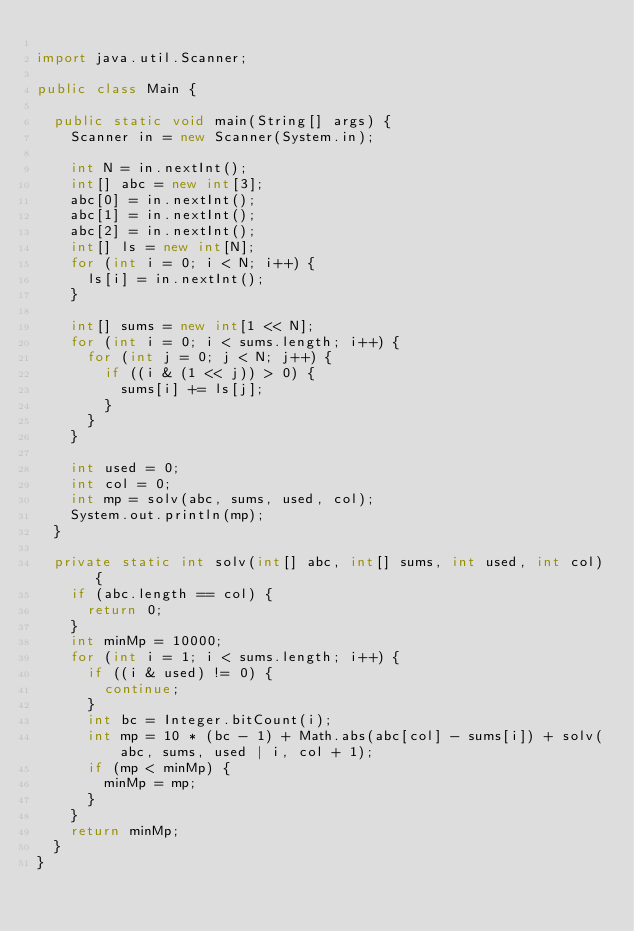<code> <loc_0><loc_0><loc_500><loc_500><_Java_>
import java.util.Scanner;

public class Main {

	public static void main(String[] args) {
		Scanner in = new Scanner(System.in);

		int N = in.nextInt();
		int[] abc = new int[3];
		abc[0] = in.nextInt();
		abc[1] = in.nextInt();
		abc[2] = in.nextInt();
		int[] ls = new int[N];
		for (int i = 0; i < N; i++) {
			ls[i] = in.nextInt();
		}

		int[] sums = new int[1 << N];
		for (int i = 0; i < sums.length; i++) {
			for (int j = 0; j < N; j++) {
				if ((i & (1 << j)) > 0) {
					sums[i] += ls[j];
				}
			}
		}

		int used = 0;
		int col = 0;
		int mp = solv(abc, sums, used, col);
		System.out.println(mp);
	}

	private static int solv(int[] abc, int[] sums, int used, int col) {
		if (abc.length == col) {
			return 0;
		}
		int minMp = 10000;
		for (int i = 1; i < sums.length; i++) {
			if ((i & used) != 0) {
				continue;
			}
			int bc = Integer.bitCount(i);
			int mp = 10 * (bc - 1) + Math.abs(abc[col] - sums[i]) + solv(abc, sums, used | i, col + 1);
			if (mp < minMp) {
				minMp = mp;
			}
		}
		return minMp;
	}
}
</code> 